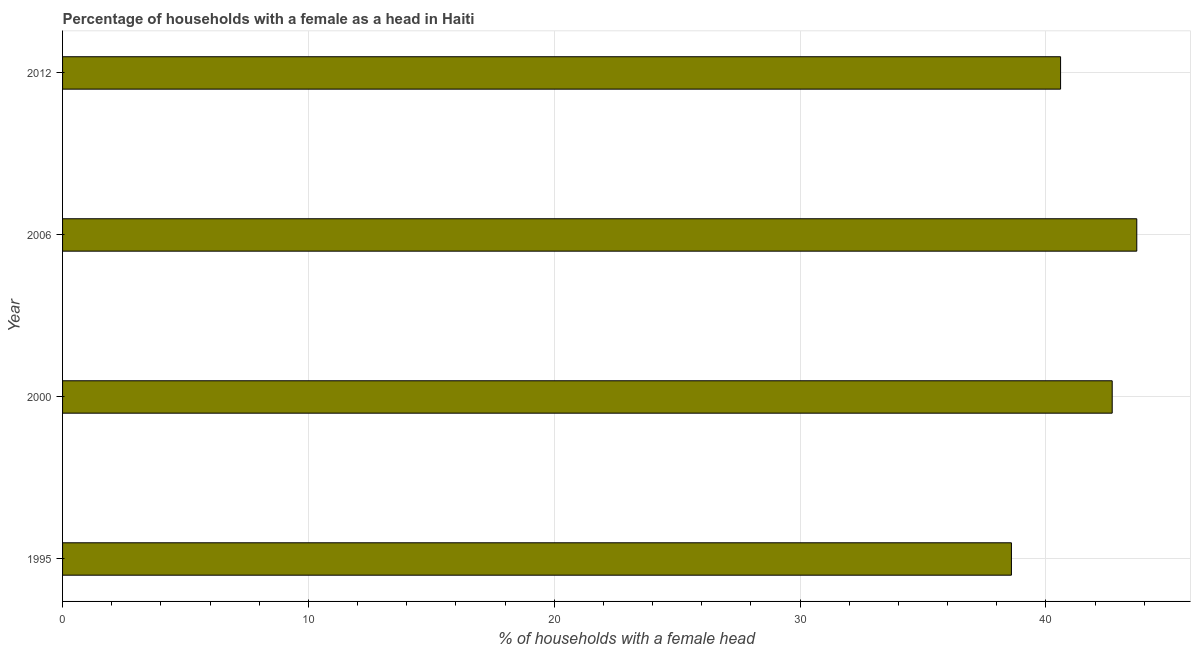What is the title of the graph?
Offer a terse response. Percentage of households with a female as a head in Haiti. What is the label or title of the X-axis?
Give a very brief answer. % of households with a female head. What is the label or title of the Y-axis?
Your response must be concise. Year. What is the number of female supervised households in 2012?
Your answer should be very brief. 40.6. Across all years, what is the maximum number of female supervised households?
Make the answer very short. 43.7. Across all years, what is the minimum number of female supervised households?
Give a very brief answer. 38.6. What is the sum of the number of female supervised households?
Ensure brevity in your answer.  165.6. What is the difference between the number of female supervised households in 1995 and 2006?
Provide a short and direct response. -5.1. What is the average number of female supervised households per year?
Offer a very short reply. 41.4. What is the median number of female supervised households?
Your answer should be very brief. 41.65. In how many years, is the number of female supervised households greater than 26 %?
Provide a succinct answer. 4. What is the ratio of the number of female supervised households in 2006 to that in 2012?
Offer a terse response. 1.08. Is the sum of the number of female supervised households in 2000 and 2006 greater than the maximum number of female supervised households across all years?
Offer a very short reply. Yes. What is the difference between the highest and the lowest number of female supervised households?
Your answer should be very brief. 5.1. How many bars are there?
Provide a short and direct response. 4. How many years are there in the graph?
Make the answer very short. 4. Are the values on the major ticks of X-axis written in scientific E-notation?
Your answer should be compact. No. What is the % of households with a female head in 1995?
Provide a short and direct response. 38.6. What is the % of households with a female head of 2000?
Make the answer very short. 42.7. What is the % of households with a female head of 2006?
Make the answer very short. 43.7. What is the % of households with a female head in 2012?
Ensure brevity in your answer.  40.6. What is the difference between the % of households with a female head in 1995 and 2000?
Provide a succinct answer. -4.1. What is the difference between the % of households with a female head in 1995 and 2006?
Ensure brevity in your answer.  -5.1. What is the difference between the % of households with a female head in 1995 and 2012?
Provide a succinct answer. -2. What is the ratio of the % of households with a female head in 1995 to that in 2000?
Offer a terse response. 0.9. What is the ratio of the % of households with a female head in 1995 to that in 2006?
Ensure brevity in your answer.  0.88. What is the ratio of the % of households with a female head in 1995 to that in 2012?
Provide a short and direct response. 0.95. What is the ratio of the % of households with a female head in 2000 to that in 2006?
Make the answer very short. 0.98. What is the ratio of the % of households with a female head in 2000 to that in 2012?
Ensure brevity in your answer.  1.05. What is the ratio of the % of households with a female head in 2006 to that in 2012?
Provide a short and direct response. 1.08. 